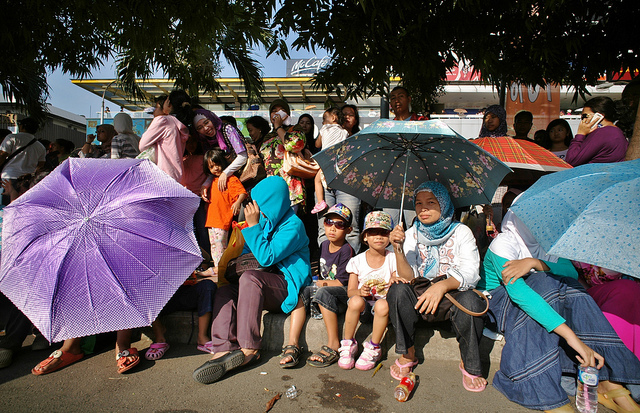Read and extract the text from this image. McCafe 